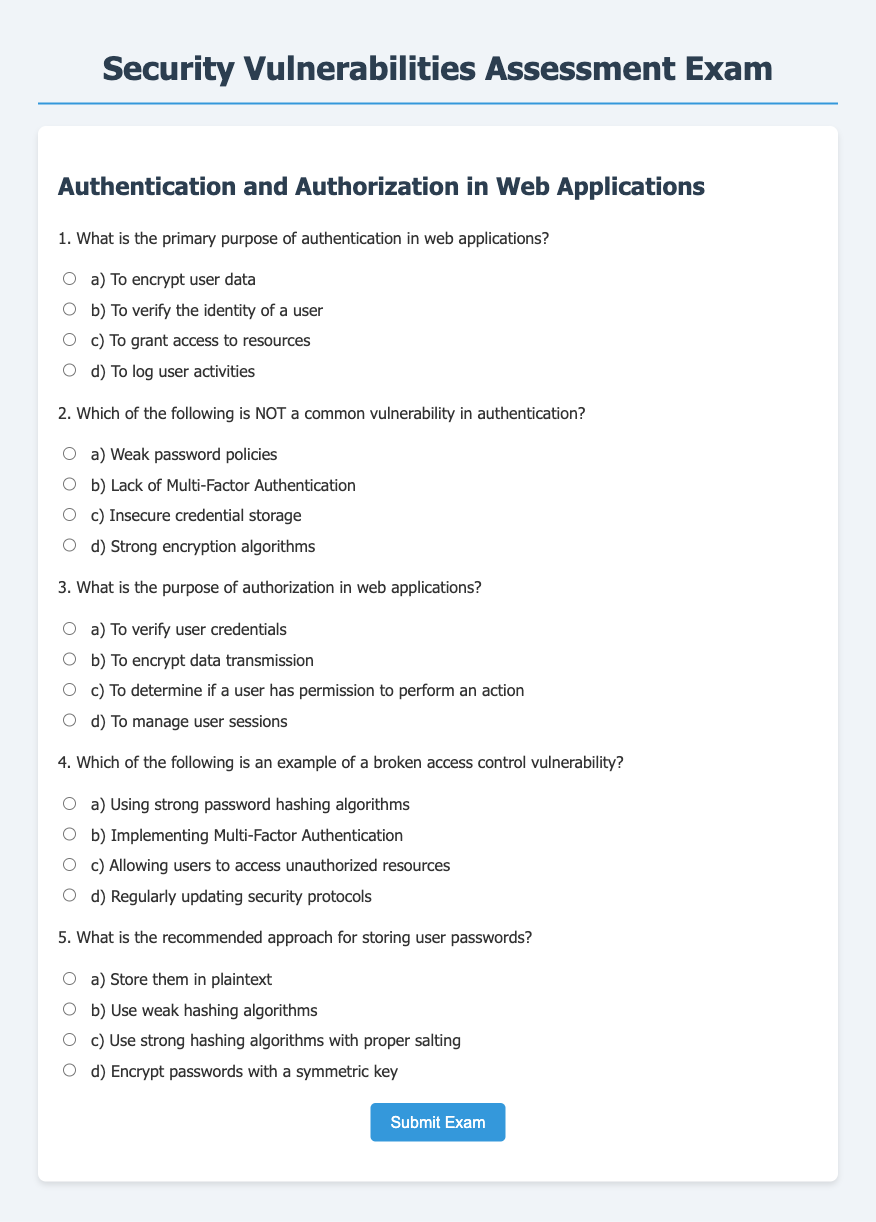What is the title of the exam? The title is stated at the top of the document, indicating the subject of the exam.
Answer: Security Vulnerabilities Assessment Exam What is the purpose of authentication in web applications? This information can be found in the first question of the exam.
Answer: To verify the identity of a user Which vulnerability is specifically mentioned as NOT common in authentication? This is specified in the second question, asking to identify the vulnerability that is not typical.
Answer: Strong encryption algorithms What does authorization in web applications aim to determine? This is detailed in the third question regarding the function of authorization.
Answer: If a user has permission to perform an action What is suggested for the recommended approach to storing user passwords? The fifth question directly addresses the best practices for password storage.
Answer: Use strong hashing algorithms with proper salting 